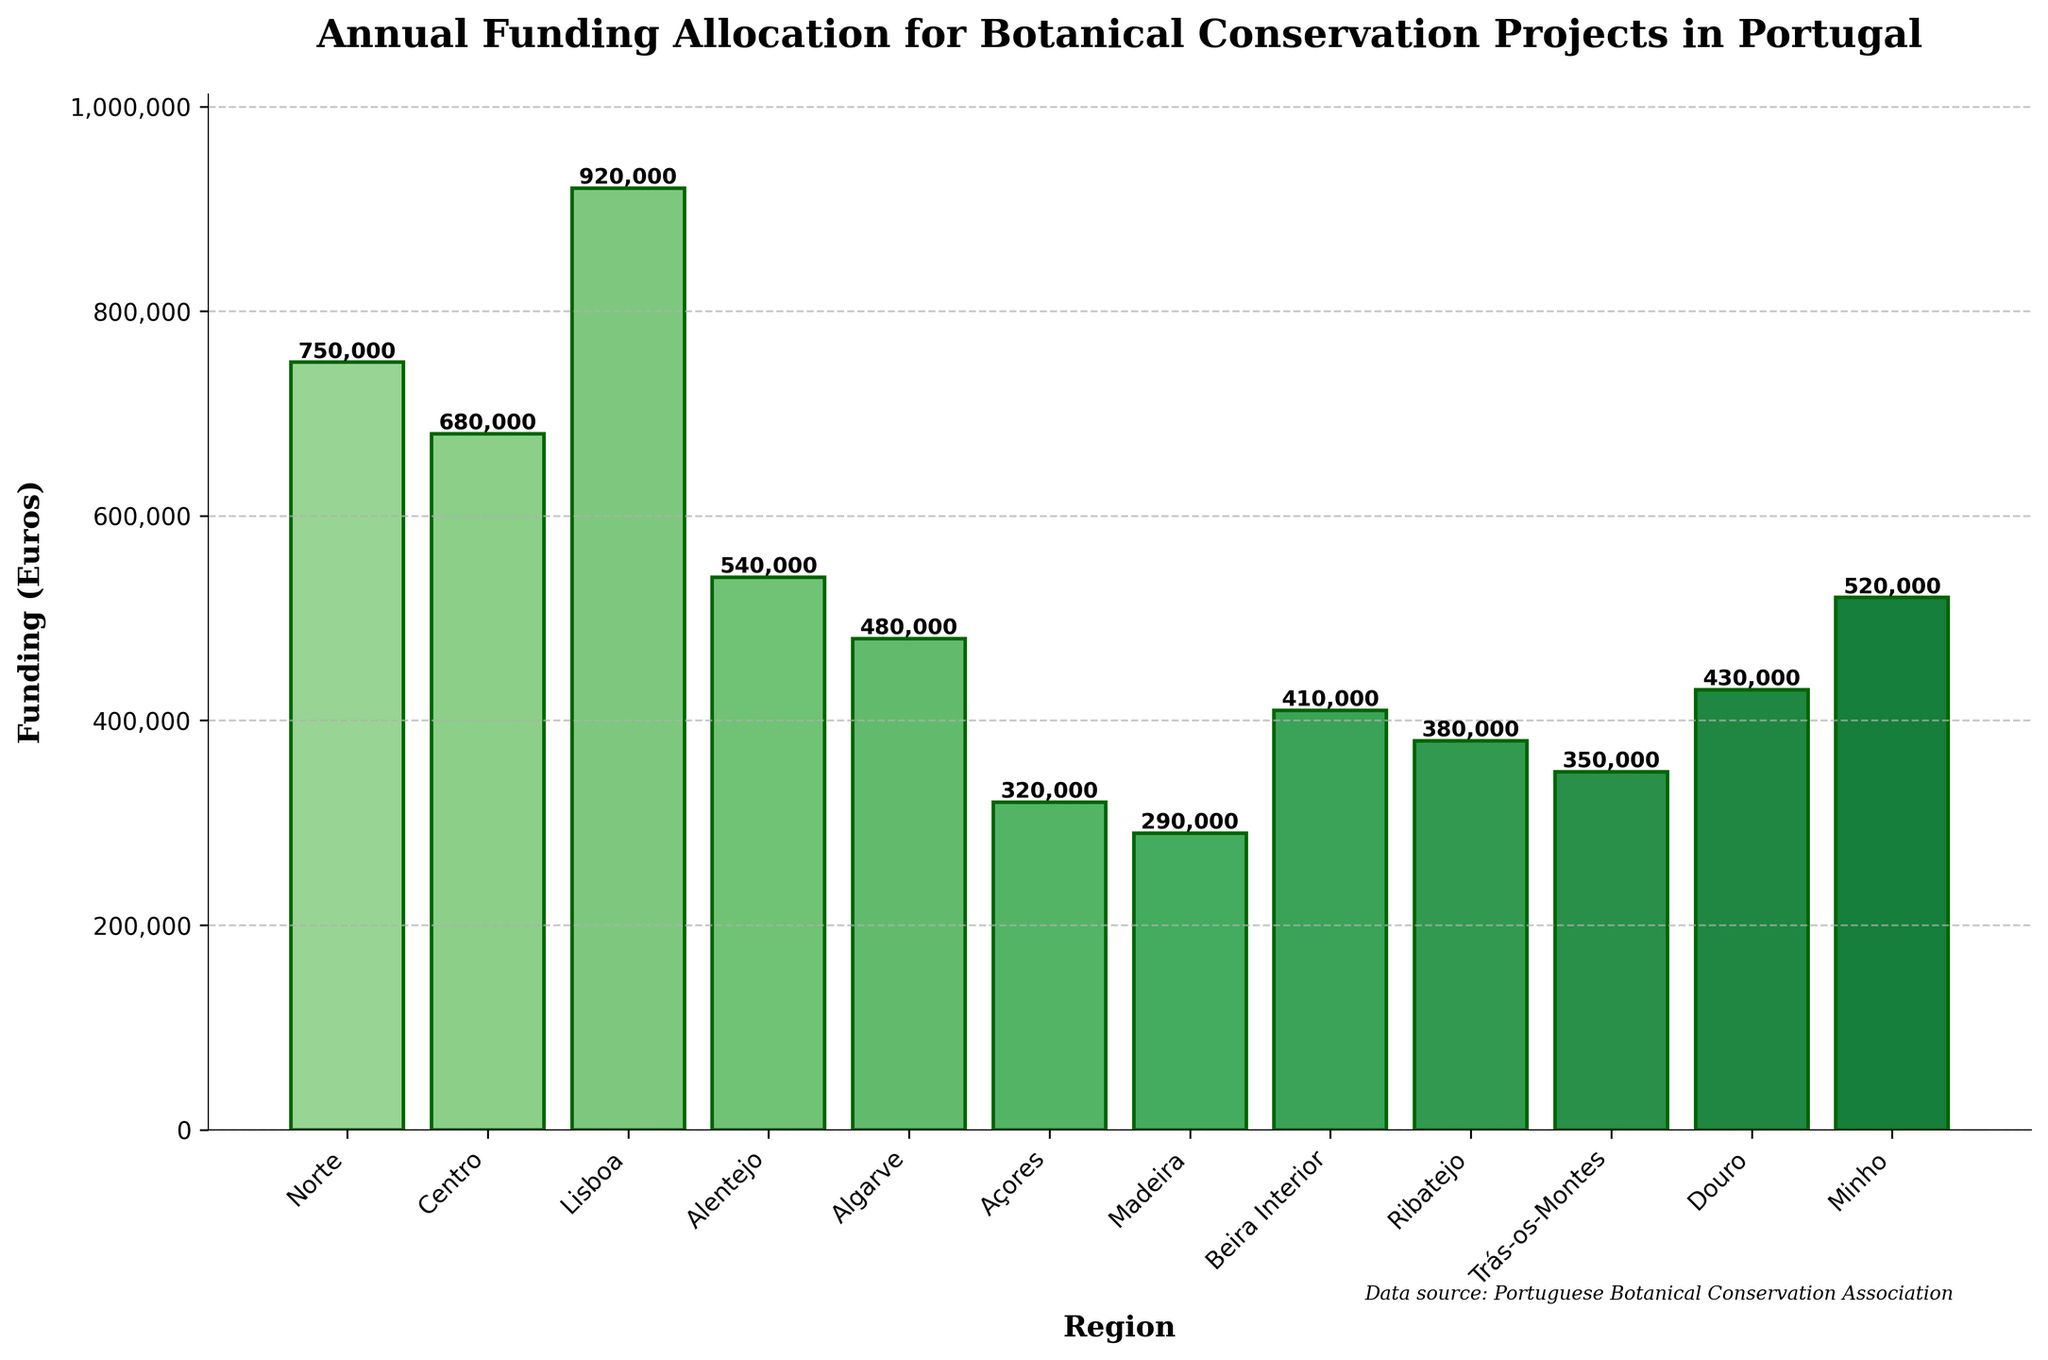Which region received the most funding? The bar for "Lisboa" is the tallest, indicating it received the most funding.
Answer: Lisboa Which region received the least funding? The bar for "Madeira" is the shortest, indicating it received the least funding.
Answer: Madeira What is the total funding allocated across all regions? Add up the funding amounts for all regions (750,000 + 680,000 + 920,000 + 540,000 + 480,000 + 320,000 + 290,000 + 410,000 + 380,000 + 350,000 + 430,000 + 520,000) = 6,070,000 Euros.
Answer: 6,070,000 Euros Which two regions combined received the same amount of funding as Lisboa? Lisboa received 920,000 Euros. The combination of Norte (750,000 Euros) and Trás-os-Montes (350,000 Euros) is 750,000 + 350,000 = 1,100,000, which is closest but not an exact match. The combination of Minho (520,000 Euros) and Centro (680,000 Euros) is 520,000 + 680,000 = 1,200,000, also not an exact match. Instead, Centro (680,000 Euros) and Algarve (480,000 Euros) sum to 1,160,000 Euros, which is still not exact. Hence, no exact match.
Answer: No exact match What is the average funding allocated per region? Divide the total funding by the number of regions: 6,070,000 Euros / 12 ≈ 505,833 Euros.
Answer: 505,833 Euros How much more funding did Norte receive compared to Centro? Norte received 750,000 Euros, and Centro received 680,000 Euros. The difference is 750,000 - 680,000 = 70,000 Euros.
Answer: 70,000 Euros Which regions received less than 400,000 Euros in funding? By examining the heights of the bars, Açores, Madeira, Ribatejo, and Trás-os-Montes all received less than 400,000 Euros in funding.
Answer: Açores, Madeira, Ribatejo, Trás-os-Montes What is the cumulative funding for the regions that received more than 500,000 Euros? Sum the funding for regions with more than 500,000 Euros: Norte (750,000), Centro (680,000), Lisboa (920,000), Alentejo (540,000), and Minho (520,000). Adding these amounts: 750,000 + 680,000 + 920,000 + 540,000 + 520,000 = 3,410,000 Euros.
Answer: 3,410,000 Euros 